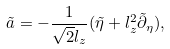<formula> <loc_0><loc_0><loc_500><loc_500>\tilde { a } = - \frac { 1 } { \sqrt { 2 } l _ { z } } ( \tilde { \eta } + l _ { z } ^ { 2 } \tilde { \partial } _ { \eta } ) ,</formula> 